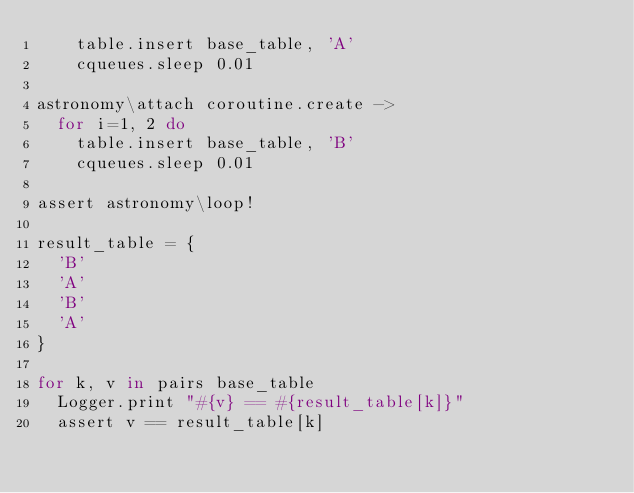Convert code to text. <code><loc_0><loc_0><loc_500><loc_500><_MoonScript_>		table.insert base_table, 'A'
		cqueues.sleep 0.01

astronomy\attach coroutine.create ->
	for i=1, 2 do
		table.insert base_table, 'B'
		cqueues.sleep 0.01

assert astronomy\loop!

result_table = {
	'B'
	'A'
	'B'
	'A'
}

for k, v in pairs base_table
	Logger.print "#{v} == #{result_table[k]}"
	assert v == result_table[k]
</code> 